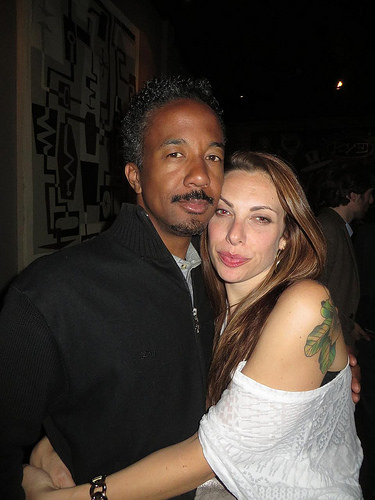<image>
Is there a man above the woman? No. The man is not positioned above the woman. The vertical arrangement shows a different relationship. 